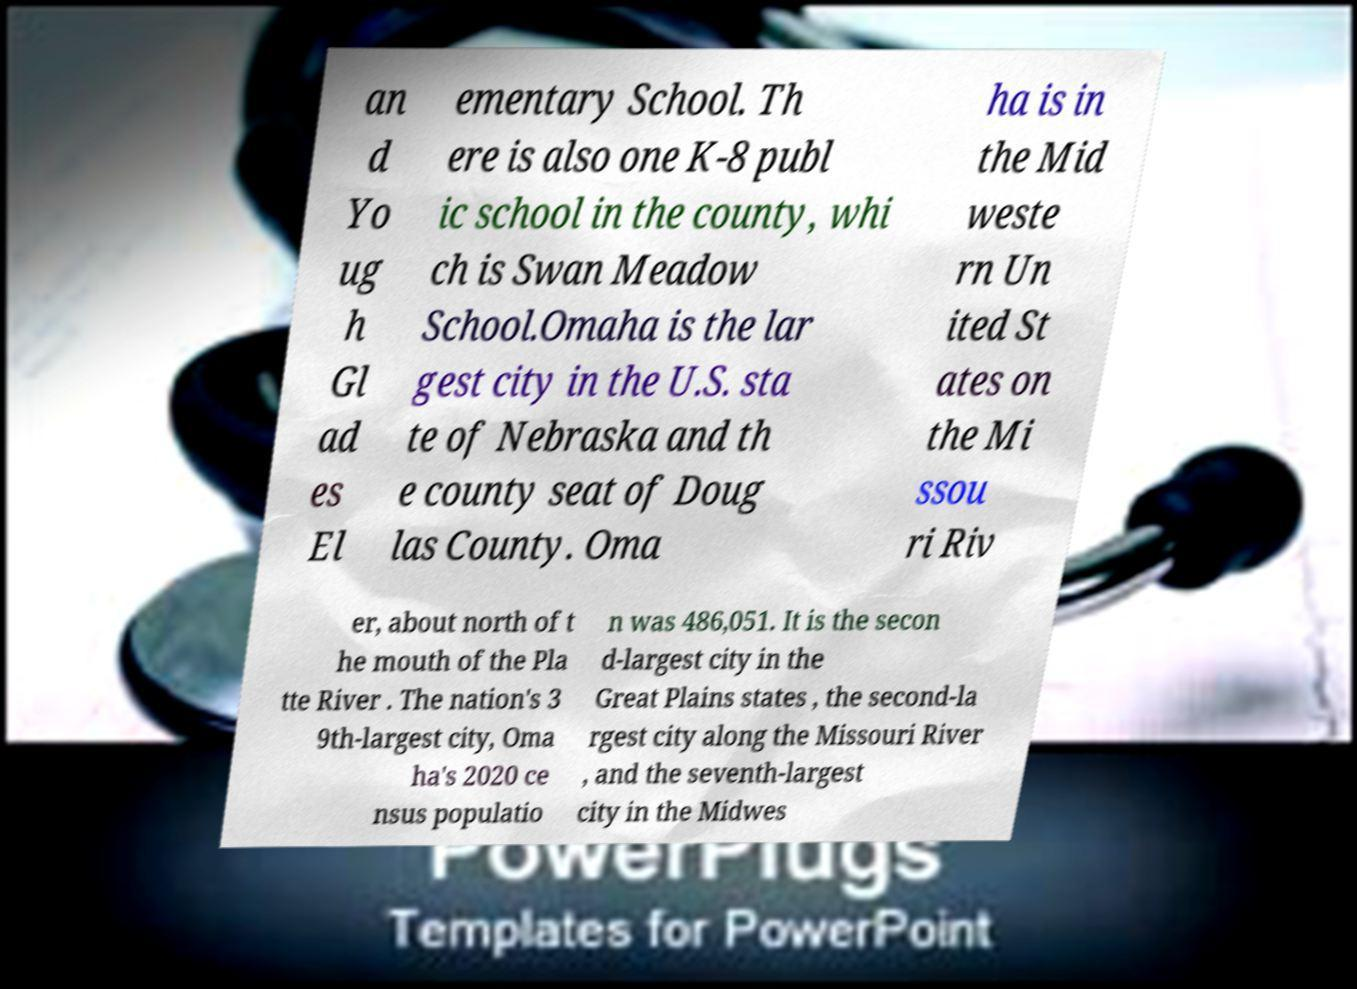Can you read and provide the text displayed in the image?This photo seems to have some interesting text. Can you extract and type it out for me? an d Yo ug h Gl ad es El ementary School. Th ere is also one K-8 publ ic school in the county, whi ch is Swan Meadow School.Omaha is the lar gest city in the U.S. sta te of Nebraska and th e county seat of Doug las County. Oma ha is in the Mid weste rn Un ited St ates on the Mi ssou ri Riv er, about north of t he mouth of the Pla tte River . The nation's 3 9th-largest city, Oma ha's 2020 ce nsus populatio n was 486,051. It is the secon d-largest city in the Great Plains states , the second-la rgest city along the Missouri River , and the seventh-largest city in the Midwes 